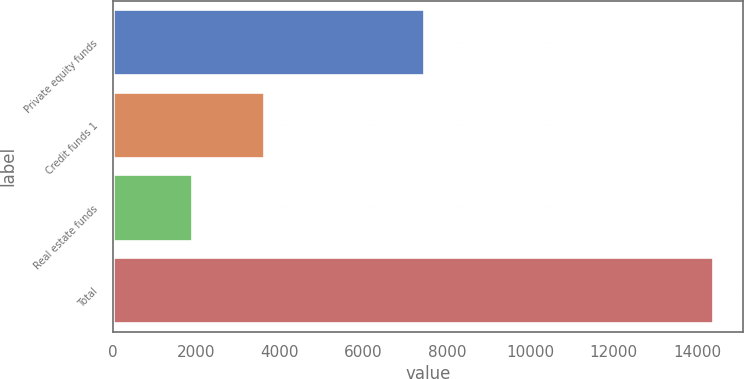<chart> <loc_0><loc_0><loc_500><loc_500><bar_chart><fcel>Private equity funds<fcel>Credit funds 1<fcel>Real estate funds<fcel>Total<nl><fcel>7446<fcel>3624<fcel>1908<fcel>14372<nl></chart> 